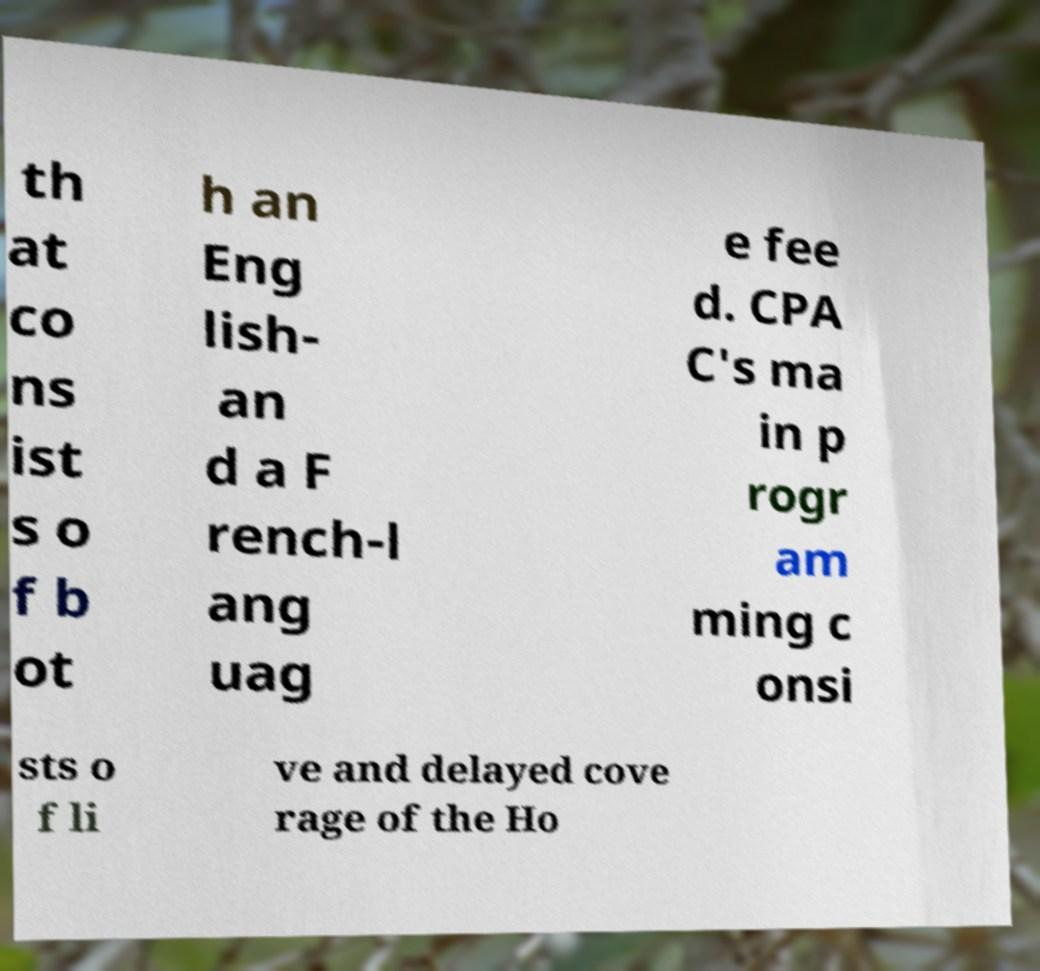Could you extract and type out the text from this image? th at co ns ist s o f b ot h an Eng lish- an d a F rench-l ang uag e fee d. CPA C's ma in p rogr am ming c onsi sts o f li ve and delayed cove rage of the Ho 